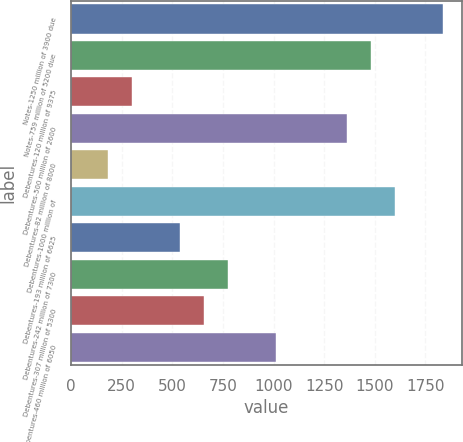<chart> <loc_0><loc_0><loc_500><loc_500><bar_chart><fcel>Notes-1250 million of 3900 due<fcel>Notes-759 million of 5200 due<fcel>Debentures-120 million of 9375<fcel>Debentures-500 million of 2600<fcel>Debentures-82 million of 8000<fcel>Debentures-1000 million of<fcel>Debentures-193 million of 6625<fcel>Debentures-242 million of 7300<fcel>Debentures-307 million of 5300<fcel>Debentures-460 million of 6050<nl><fcel>1837<fcel>1482.4<fcel>300.4<fcel>1364.2<fcel>182.2<fcel>1600.6<fcel>536.8<fcel>773.2<fcel>655<fcel>1009.6<nl></chart> 